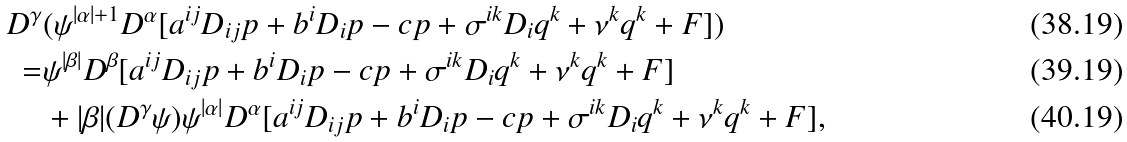Convert formula to latex. <formula><loc_0><loc_0><loc_500><loc_500>D ^ { \gamma } & ( \psi ^ { | \alpha | + 1 } D ^ { \alpha } [ a ^ { i j } D _ { i j } p + b ^ { i } D _ { i } p - c p + \sigma ^ { i k } D _ { i } q ^ { k } + \nu ^ { k } q ^ { k } + F ] ) \\ = & \psi ^ { | \beta | } D ^ { \beta } [ a ^ { i j } D _ { i j } p + b ^ { i } D _ { i } p - c p + \sigma ^ { i k } D _ { i } q ^ { k } + \nu ^ { k } q ^ { k } + F ] \\ & + | \beta | ( D ^ { \gamma } \psi ) \psi ^ { | \alpha | } D ^ { \alpha } [ a ^ { i j } D _ { i j } p + b ^ { i } D _ { i } p - c p + \sigma ^ { i k } D _ { i } q ^ { k } + \nu ^ { k } q ^ { k } + F ] ,</formula> 